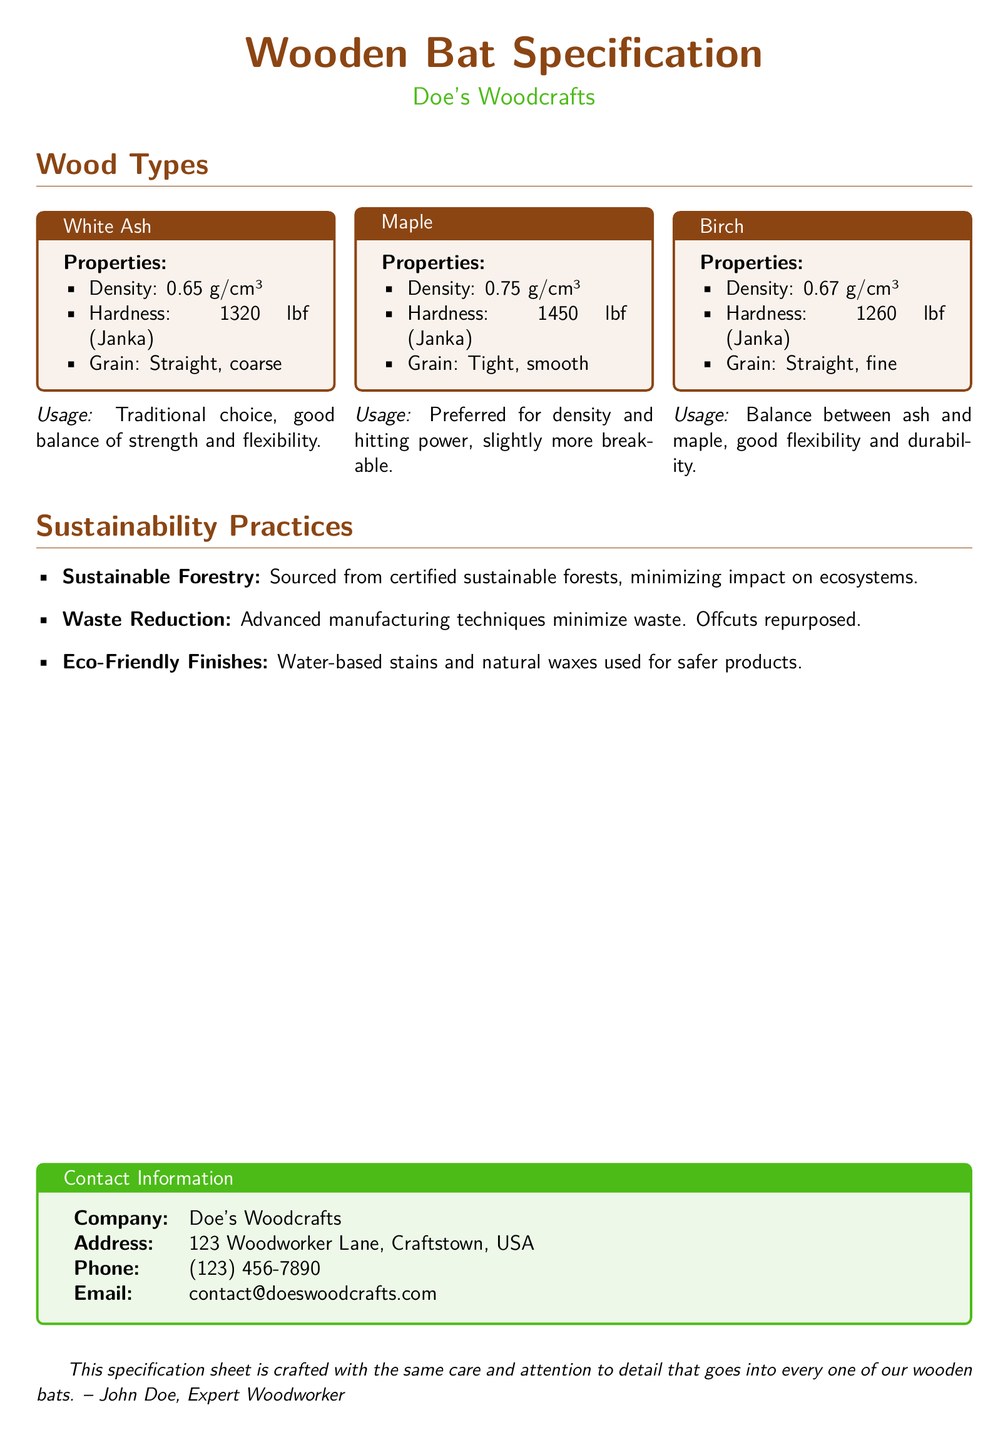What wood type has the highest density? The density of each wood type is listed in the document, and Maple has the highest density at 0.75 g/cm³.
Answer: 0.75 g/cm³ What is the hardness rating of White Ash? The hardness rating, measured in Janka, for White Ash is detailed in the document as 1320 lbf.
Answer: 1320 lbf What wood type is preferred for hitting power? The document states that Maple is preferred for its density and hitting power.
Answer: Maple Which wood type provides a balance between strength and flexibility? The usage description for White Ash indicates that it provides a good balance of strength and flexibility.
Answer: White Ash What is the company name mentioned in the document? The contact information section clearly lists the company name as Doe's Woodcrafts.
Answer: Doe's Woodcrafts What sustainable practice is mentioned in terms of waste? The document notes advanced manufacturing techniques for waste reduction, indicating a commitment to minimizing waste.
Answer: Waste Reduction Which wood type has a grain described as "Tight, smooth"? The description provided for Maple specifies that its grain is tight and smooth.
Answer: Maple What type of finishes are used in the production? The document mentions eco-friendly finishes, specifically water-based stains and natural waxes.
Answer: Water-based stains and natural waxes 